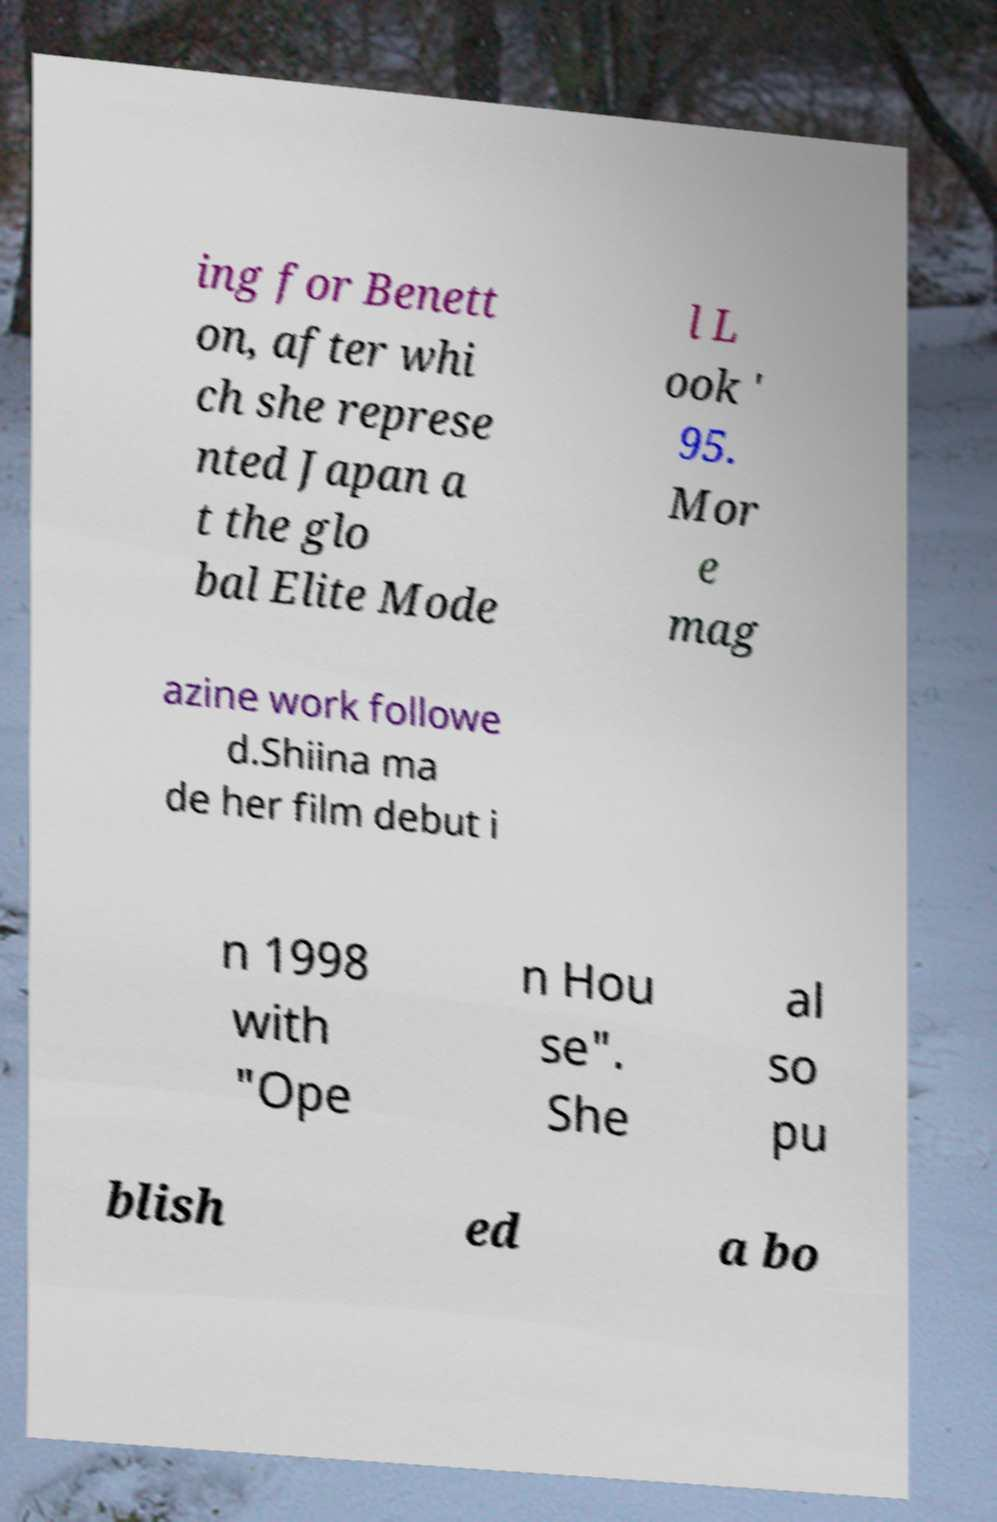Please read and relay the text visible in this image. What does it say? ing for Benett on, after whi ch she represe nted Japan a t the glo bal Elite Mode l L ook ' 95. Mor e mag azine work followe d.Shiina ma de her film debut i n 1998 with "Ope n Hou se". She al so pu blish ed a bo 